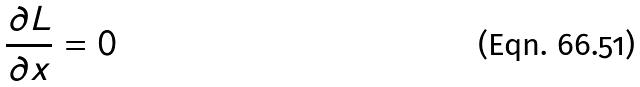Convert formula to latex. <formula><loc_0><loc_0><loc_500><loc_500>\frac { \partial L } { \partial x } = 0</formula> 